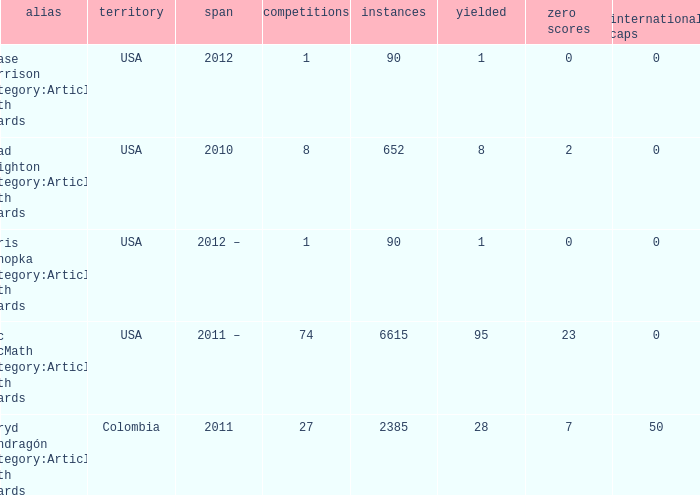When chase harrison category:articles with hcards is the name what is the year? 2012.0. 